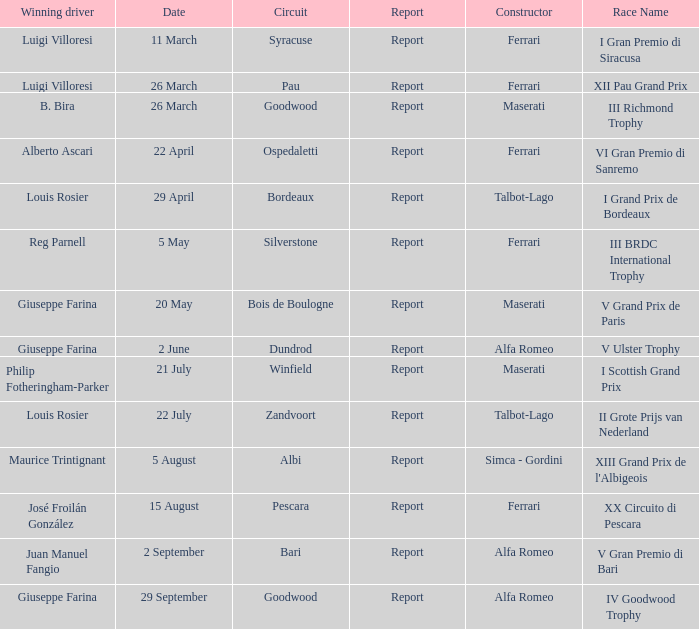Name the report for v grand prix de paris Report. 